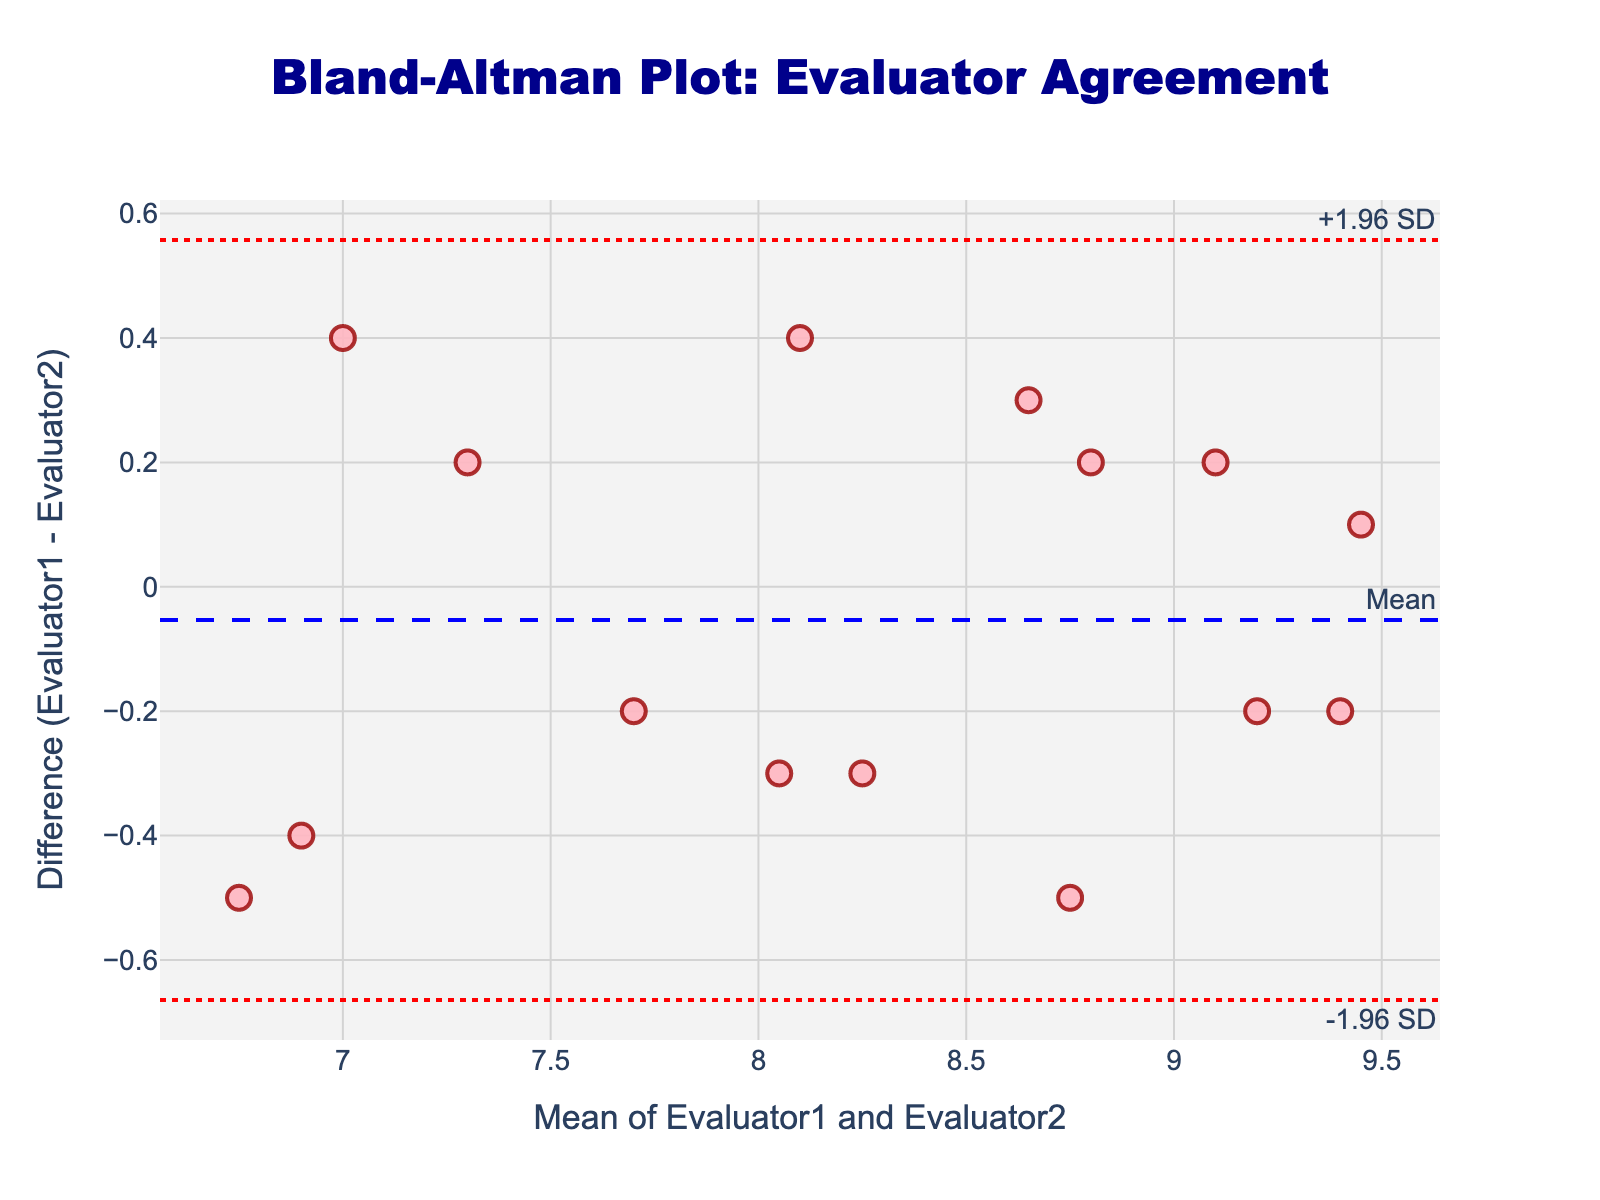What is the title of the Bland-Altman plot? The title can be found on the top of the plot, centered and in dark blue color. It clearly states the content of the plot.
Answer: Bland-Altman Plot: Evaluator Agreement How many data points are plotted in the Bland-Altman plot? Each marker on the plot represents one data point, and counting these markers provides the total number of data points.
Answer: 15 What is the color of the data points in the plot? The color of the data points can be visually identified from the plot.
Answer: Pink What's the mean line value in the plot? The mean line value can be found directly from the horizontal line marked "Mean" in blue color on the plot.
Answer: -0.01 What are the upper and lower limits of agreement in the plot? The upper and lower limits of agreement are marked with dotted lines and labeled "+1.96 SD" and "-1.96 SD" respectively on the plot.
Answer: Upper LoA is 0.61 and Lower LoA is -0.63 On average, do Evaluator1 and Evaluator2 give similar ratings? The average similarity of ratings can be observed from the mean difference line; if it's near zero, it indicates similarity.
Answer: Yes Is there a trend in the differences as the mean rating increases? A trend can be observed if the data points form a pattern (e.g., increasing or decreasing) as you move left to right along the mean axis.
Answer: No clear trend Which evaluator tends to give higher ratings based on the mean difference? The mean difference line indicates whether Evaluator1 gives higher or lower ratings on average. If the mean difference is positive, Evaluator1 tends to give higher ratings; if negative, lower ratings.
Answer: Evaluator2 How many data points fall outside the limits of agreement? Identifying points outside the upper and lower dotted lines labeled "+1.96 SD" and "-1.96 SD" provides this information.
Answer: None 